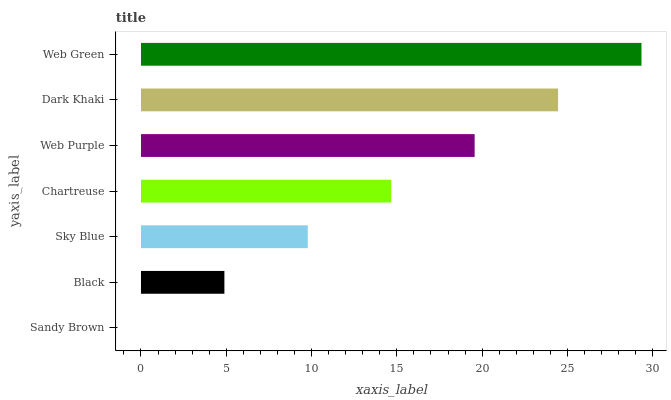Is Sandy Brown the minimum?
Answer yes or no. Yes. Is Web Green the maximum?
Answer yes or no. Yes. Is Black the minimum?
Answer yes or no. No. Is Black the maximum?
Answer yes or no. No. Is Black greater than Sandy Brown?
Answer yes or no. Yes. Is Sandy Brown less than Black?
Answer yes or no. Yes. Is Sandy Brown greater than Black?
Answer yes or no. No. Is Black less than Sandy Brown?
Answer yes or no. No. Is Chartreuse the high median?
Answer yes or no. Yes. Is Chartreuse the low median?
Answer yes or no. Yes. Is Black the high median?
Answer yes or no. No. Is Web Green the low median?
Answer yes or no. No. 